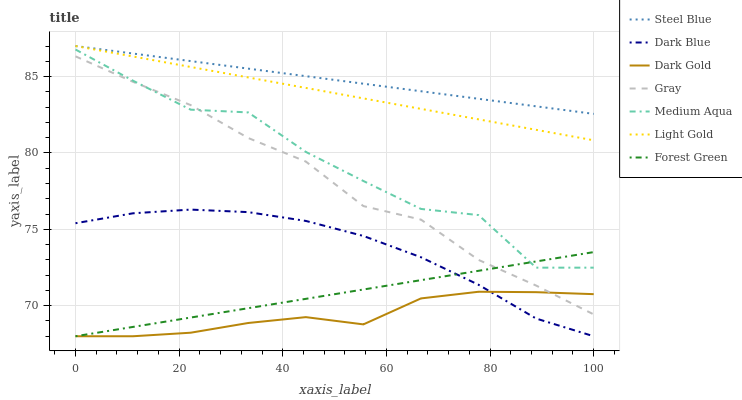Does Dark Gold have the minimum area under the curve?
Answer yes or no. Yes. Does Steel Blue have the maximum area under the curve?
Answer yes or no. Yes. Does Steel Blue have the minimum area under the curve?
Answer yes or no. No. Does Dark Gold have the maximum area under the curve?
Answer yes or no. No. Is Steel Blue the smoothest?
Answer yes or no. Yes. Is Medium Aqua the roughest?
Answer yes or no. Yes. Is Dark Gold the smoothest?
Answer yes or no. No. Is Dark Gold the roughest?
Answer yes or no. No. Does Dark Gold have the lowest value?
Answer yes or no. Yes. Does Steel Blue have the lowest value?
Answer yes or no. No. Does Light Gold have the highest value?
Answer yes or no. Yes. Does Dark Gold have the highest value?
Answer yes or no. No. Is Gray less than Light Gold?
Answer yes or no. Yes. Is Light Gold greater than Dark Blue?
Answer yes or no. Yes. Does Forest Green intersect Medium Aqua?
Answer yes or no. Yes. Is Forest Green less than Medium Aqua?
Answer yes or no. No. Is Forest Green greater than Medium Aqua?
Answer yes or no. No. Does Gray intersect Light Gold?
Answer yes or no. No. 